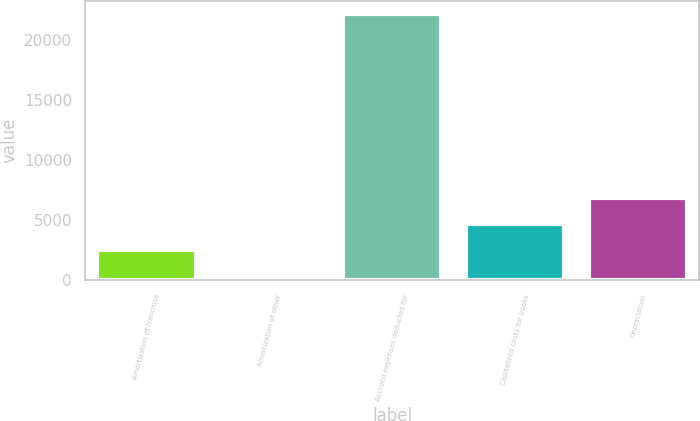Convert chart to OTSL. <chart><loc_0><loc_0><loc_500><loc_500><bar_chart><fcel>Amortization of franchise<fcel>Amortization of other<fcel>Accrued expenses deducted for<fcel>Capitalized costs for books<fcel>Depreciation<nl><fcel>2520.5<fcel>339<fcel>22154<fcel>4702<fcel>6883.5<nl></chart> 